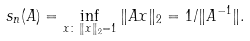<formula> <loc_0><loc_0><loc_500><loc_500>s _ { n } ( A ) = \inf _ { x \colon \, \| x \| _ { 2 } = 1 } \| A x \| _ { 2 } = 1 / \| A ^ { - 1 } \| .</formula> 